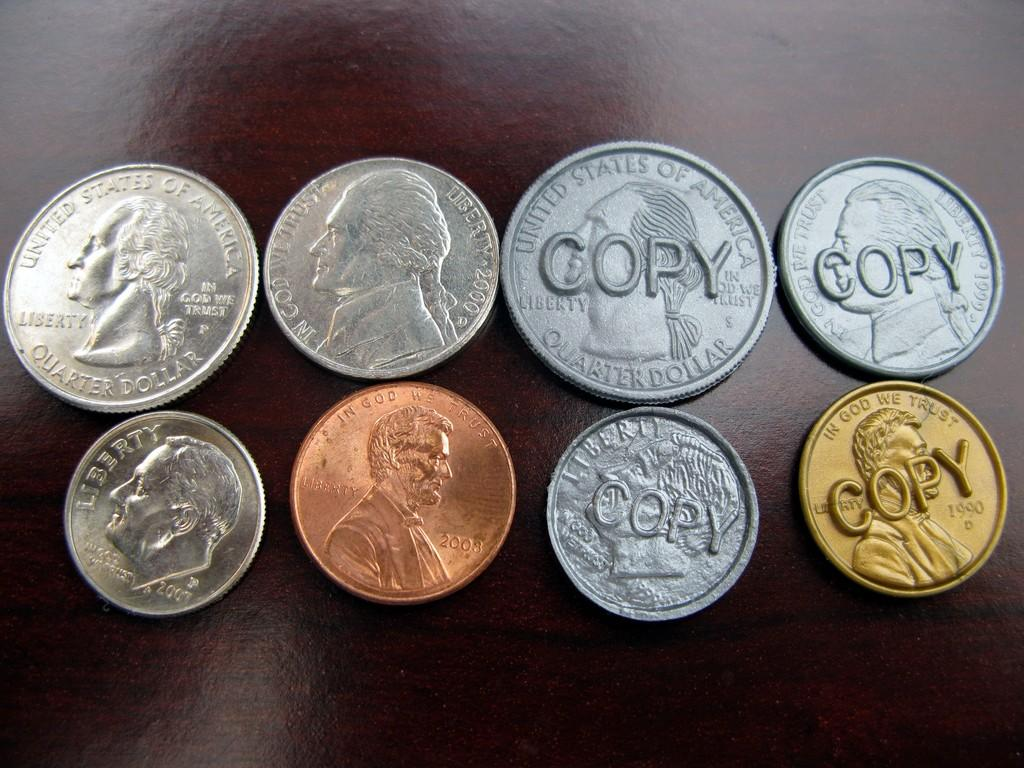<image>
Summarize the visual content of the image. Four coins sat on a table have the word copy printed on them. 